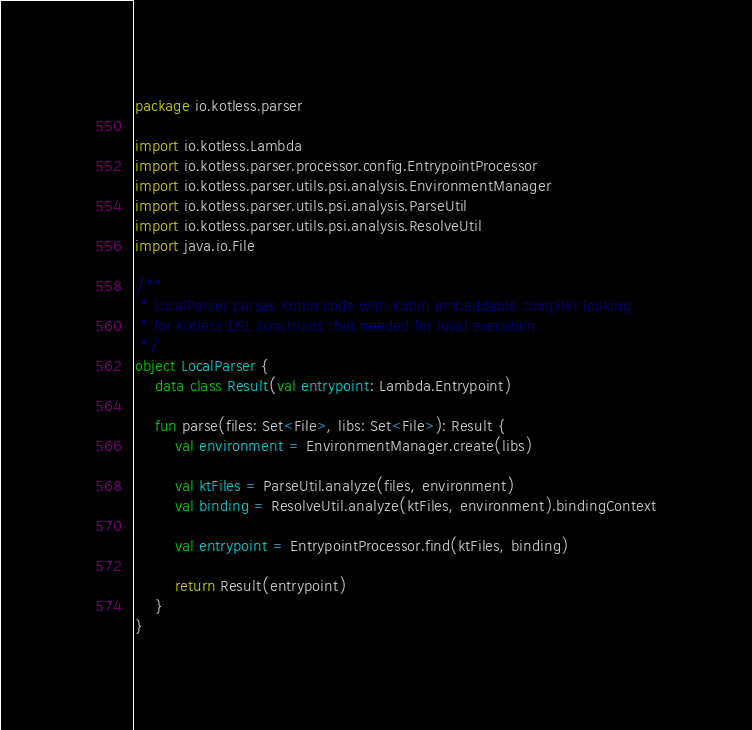Convert code to text. <code><loc_0><loc_0><loc_500><loc_500><_Kotlin_>package io.kotless.parser

import io.kotless.Lambda
import io.kotless.parser.processor.config.EntrypointProcessor
import io.kotless.parser.utils.psi.analysis.EnvironmentManager
import io.kotless.parser.utils.psi.analysis.ParseUtil
import io.kotless.parser.utils.psi.analysis.ResolveUtil
import java.io.File

/**
 * LocalParser parses Kotlin code with Kotlin embeddable compiler looking
 * for Kotless DSL constructs that needed for local execution.
 */
object LocalParser {
    data class Result(val entrypoint: Lambda.Entrypoint)

    fun parse(files: Set<File>, libs: Set<File>): Result {
        val environment = EnvironmentManager.create(libs)

        val ktFiles = ParseUtil.analyze(files, environment)
        val binding = ResolveUtil.analyze(ktFiles, environment).bindingContext

        val entrypoint = EntrypointProcessor.find(ktFiles, binding)

        return Result(entrypoint)
    }
}
</code> 